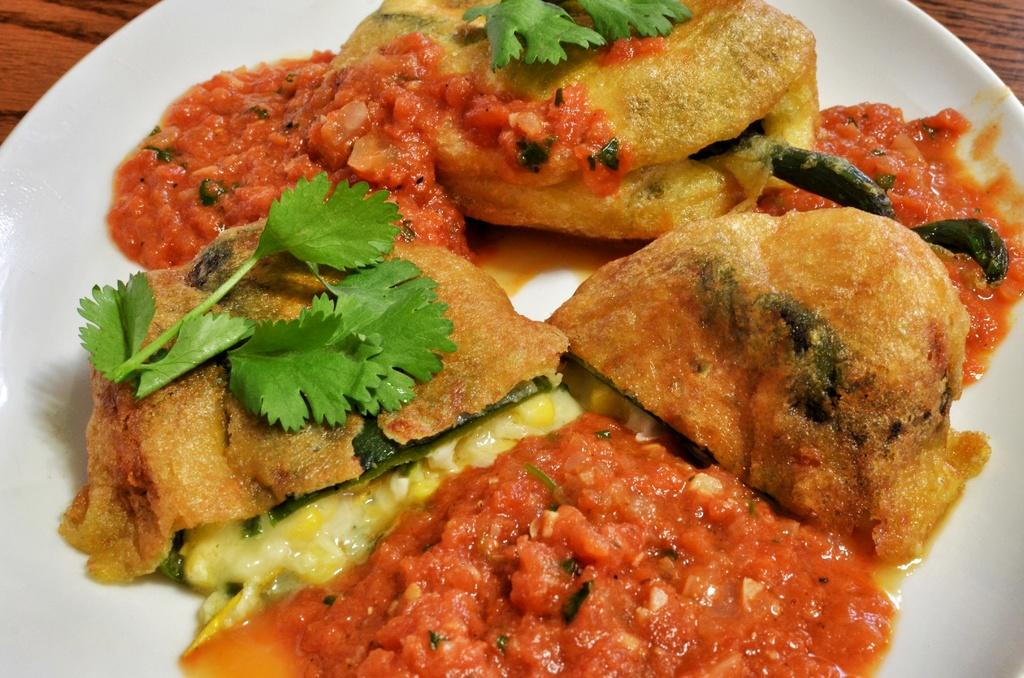What is on the white plate in the image? There is food on a white plate in the image. What type of surface is visible on the right side of the image? There is a wooden surface visible on the right side of the image. What type of surface is visible on the left side of the image? There is a wooden surface visible on the left side of the image. Is there a boat involved in the fight depicted in the image? There is no fight or boat present in the image; it only features food on a white plate and wooden surfaces on both sides. 